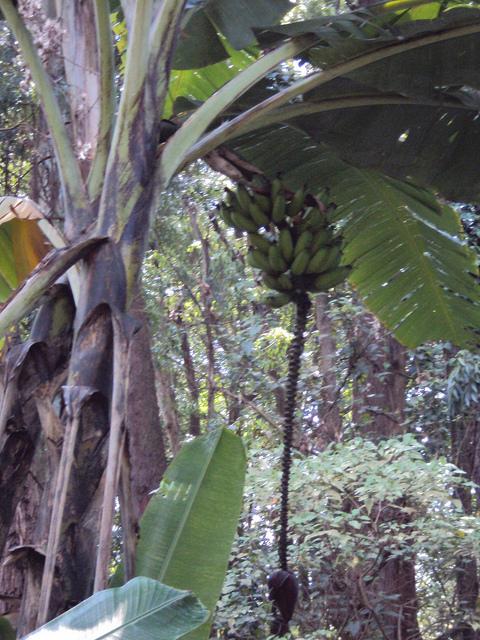What is this fruit?
Short answer required. Banana. Is this fruit still on the tree?
Answer briefly. Yes. Is this green edible used to create mass-produced baby food?
Write a very short answer. Yes. 